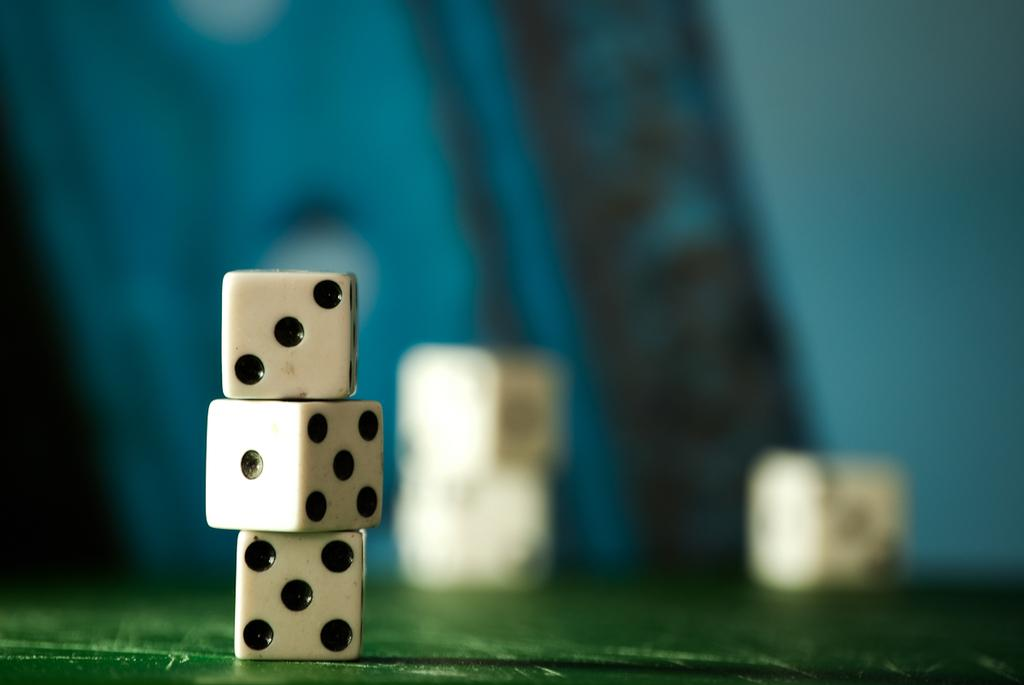What objects are present in the foreground of the image? There are cubes in the foreground of the image. What can be seen in the background of the image? There are more cubes in the background of the image. What type of wax is being used to create the cubes in the image? There is no indication in the image that wax is being used to create the cubes, and therefore no such information can be determined. 